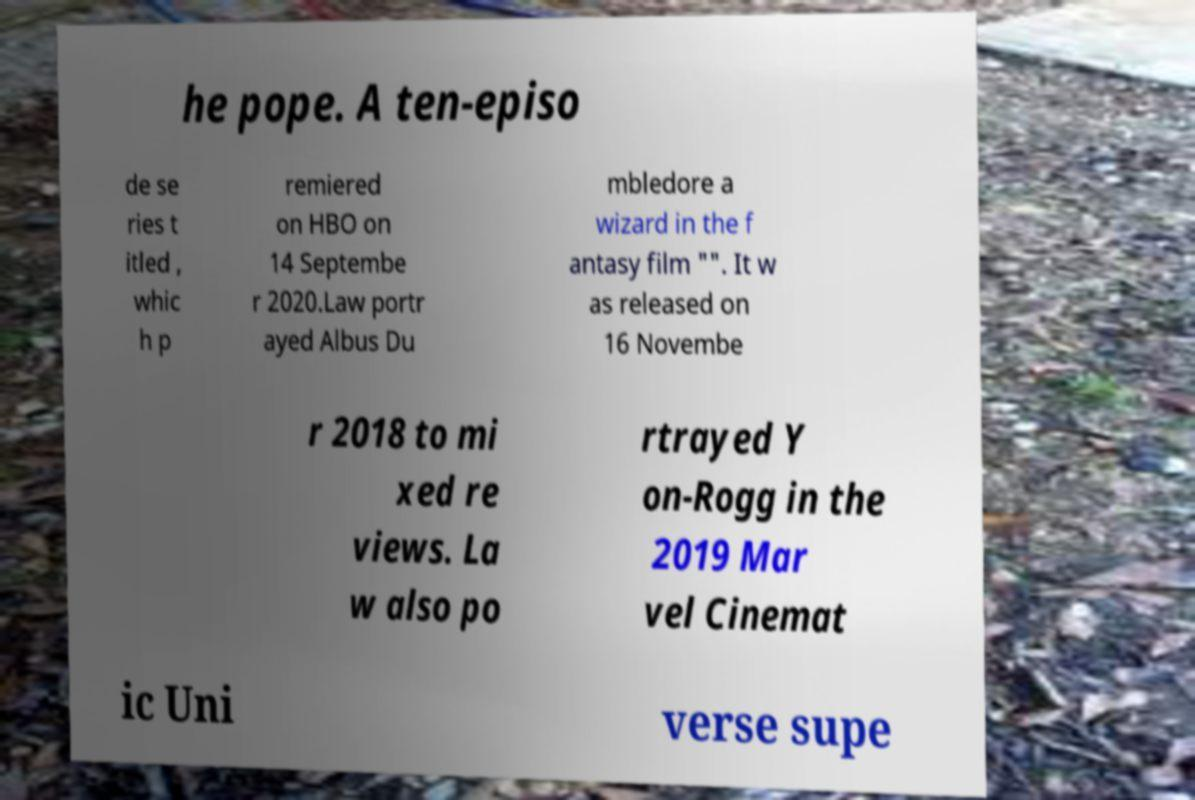Could you extract and type out the text from this image? he pope. A ten-episo de se ries t itled , whic h p remiered on HBO on 14 Septembe r 2020.Law portr ayed Albus Du mbledore a wizard in the f antasy film "". It w as released on 16 Novembe r 2018 to mi xed re views. La w also po rtrayed Y on-Rogg in the 2019 Mar vel Cinemat ic Uni verse supe 